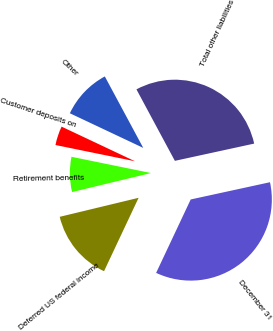<chart> <loc_0><loc_0><loc_500><loc_500><pie_chart><fcel>December 31<fcel>Deferred US federal income<fcel>Retirement benefits<fcel>Customer deposits on<fcel>Other<fcel>Total other liabilities<nl><fcel>35.41%<fcel>14.23%<fcel>6.97%<fcel>3.81%<fcel>10.13%<fcel>29.44%<nl></chart> 